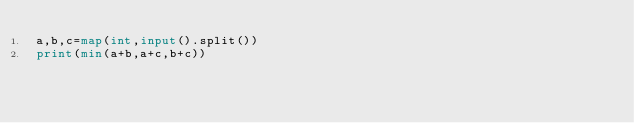<code> <loc_0><loc_0><loc_500><loc_500><_Python_>a,b,c=map(int,input().split())
print(min(a+b,a+c,b+c))
</code> 